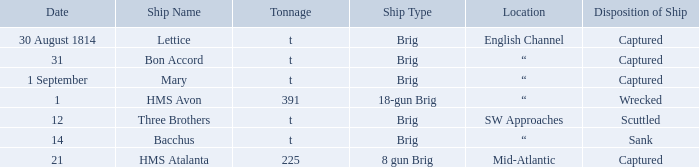What was the fate of the brig situated in the english channel? Captured. 